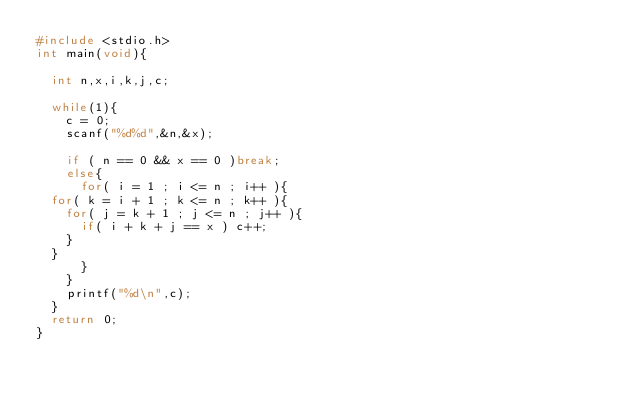<code> <loc_0><loc_0><loc_500><loc_500><_C_>#include <stdio.h>
int main(void){
  
  int n,x,i,k,j,c;
  
  while(1){
    c = 0;
    scanf("%d%d",&n,&x);
    
    if ( n == 0 && x == 0 )break;
    else{
      for( i = 1 ; i <= n ; i++ ){
	for( k = i + 1 ; k <= n ; k++ ){
	  for( j = k + 1 ; j <= n ; j++ ){
	    if( i + k + j == x ) c++;
	  }
	}
      }
    }
    printf("%d\n",c);
  }
  return 0;
}</code> 